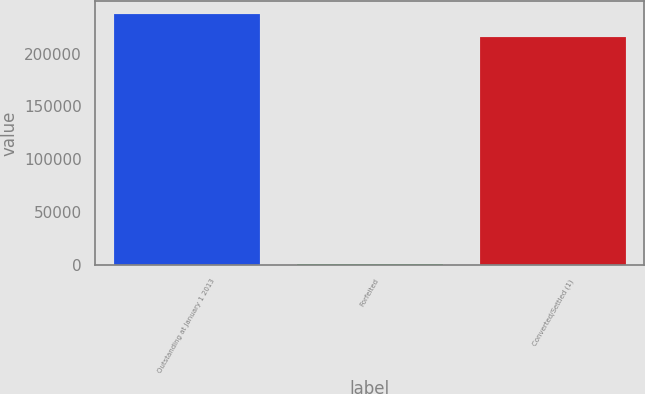<chart> <loc_0><loc_0><loc_500><loc_500><bar_chart><fcel>Outstanding at January 1 2013<fcel>Forfeited<fcel>Converted/Settled (1)<nl><fcel>237585<fcel>860<fcel>216023<nl></chart> 